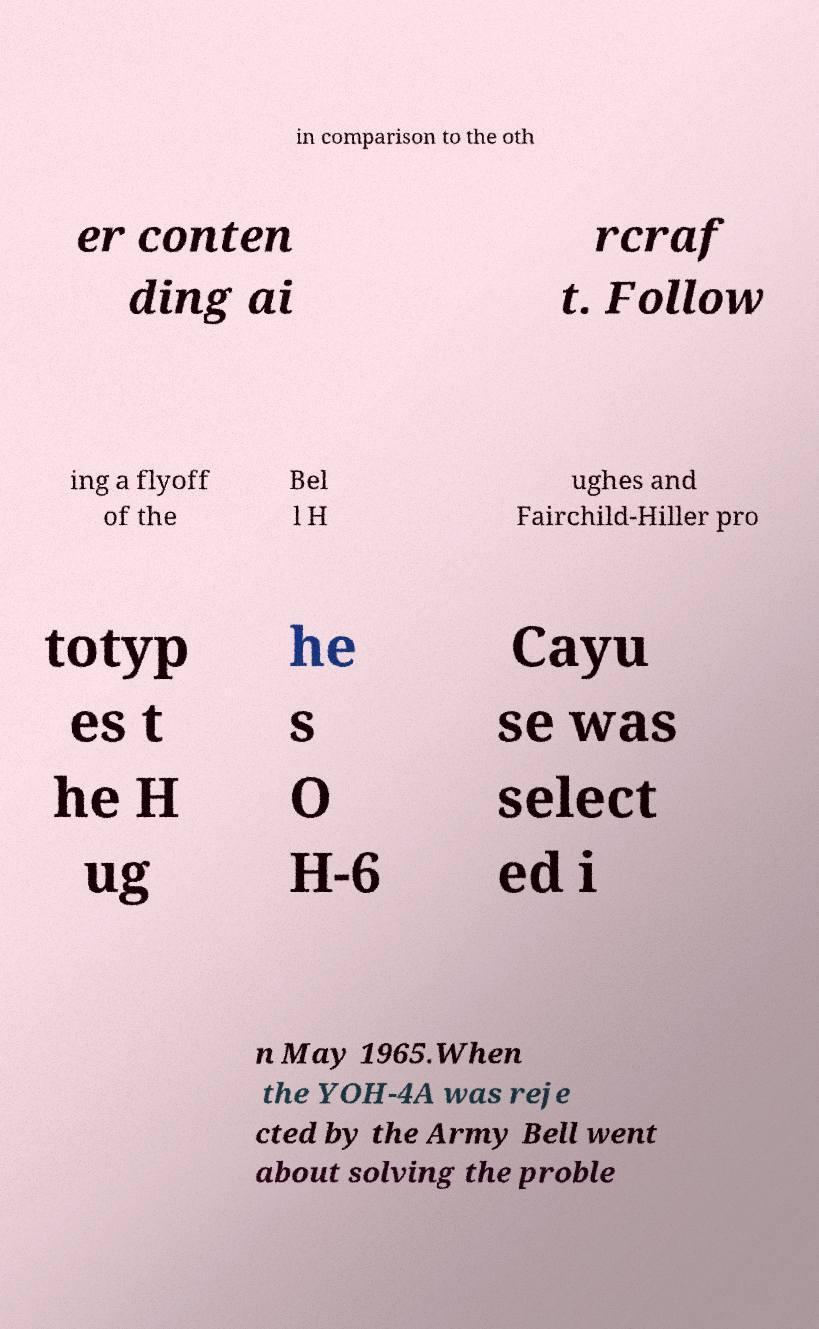Can you read and provide the text displayed in the image?This photo seems to have some interesting text. Can you extract and type it out for me? in comparison to the oth er conten ding ai rcraf t. Follow ing a flyoff of the Bel l H ughes and Fairchild-Hiller pro totyp es t he H ug he s O H-6 Cayu se was select ed i n May 1965.When the YOH-4A was reje cted by the Army Bell went about solving the proble 